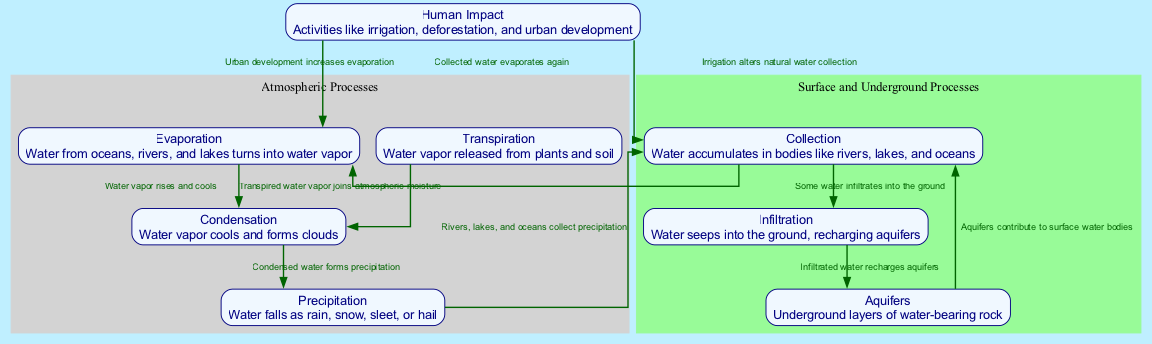What is the process where water from oceans, rivers, and lakes turns into water vapor? The diagram identifies "Evaporation" as the process where water from oceans, rivers, and lakes turns into water vapor. The label and description in the node clearly define it as the starting point of the water cycle.
Answer: Evaporation How many nodes are present in the diagram? To find the number of nodes, we can count the distinct processes described in the diagram. There are eight unique nodes representing different stages of the water cycle.
Answer: 8 What process follows condensation in the water cycle? The flow of the diagram shows that after "Condensation" occurs, the next process is "Precipitation," where condensed water falls as rain, snow, sleet, or hail.
Answer: Precipitation What is the term for underground layers of water-bearing rock? The diagram features a node labeled "Aquifers," which specifically describes underground layers of water-bearing rock. This is a straightforward identification of the node's label.
Answer: Aquifers How do human activities like irrigation affect water collection? The diagram illustrates the relationship between "Human Impact" and "Collection." It notes that human activities like irrigation alter the natural water collection process, suggesting a disruption or change related to how water is gathered.
Answer: Alters natural water collection What is one way urban development impacts evaporation? According to the diagram, "Urban development increases evaporation," which suggests that the activities associated with urbanization influence the rate at which water vaporizes into the atmosphere.
Answer: Increases evaporation Which process contributes to the recharge of aquifers? "Infiltration" is the process where water seeps into the ground, recharging aquifers. The diagram indicates a direct connection between infiltration and aquifer replenishment.
Answer: Infiltration What is the last stage of water collection before water returns to evaporation? The diagram shows that after the process of "Collection," where water accumulates in bodies like rivers, lakes, and oceans, the next step is returning to "Evaporation." This illustrates the cyclical nature of the water cycle.
Answer: Evaporation 